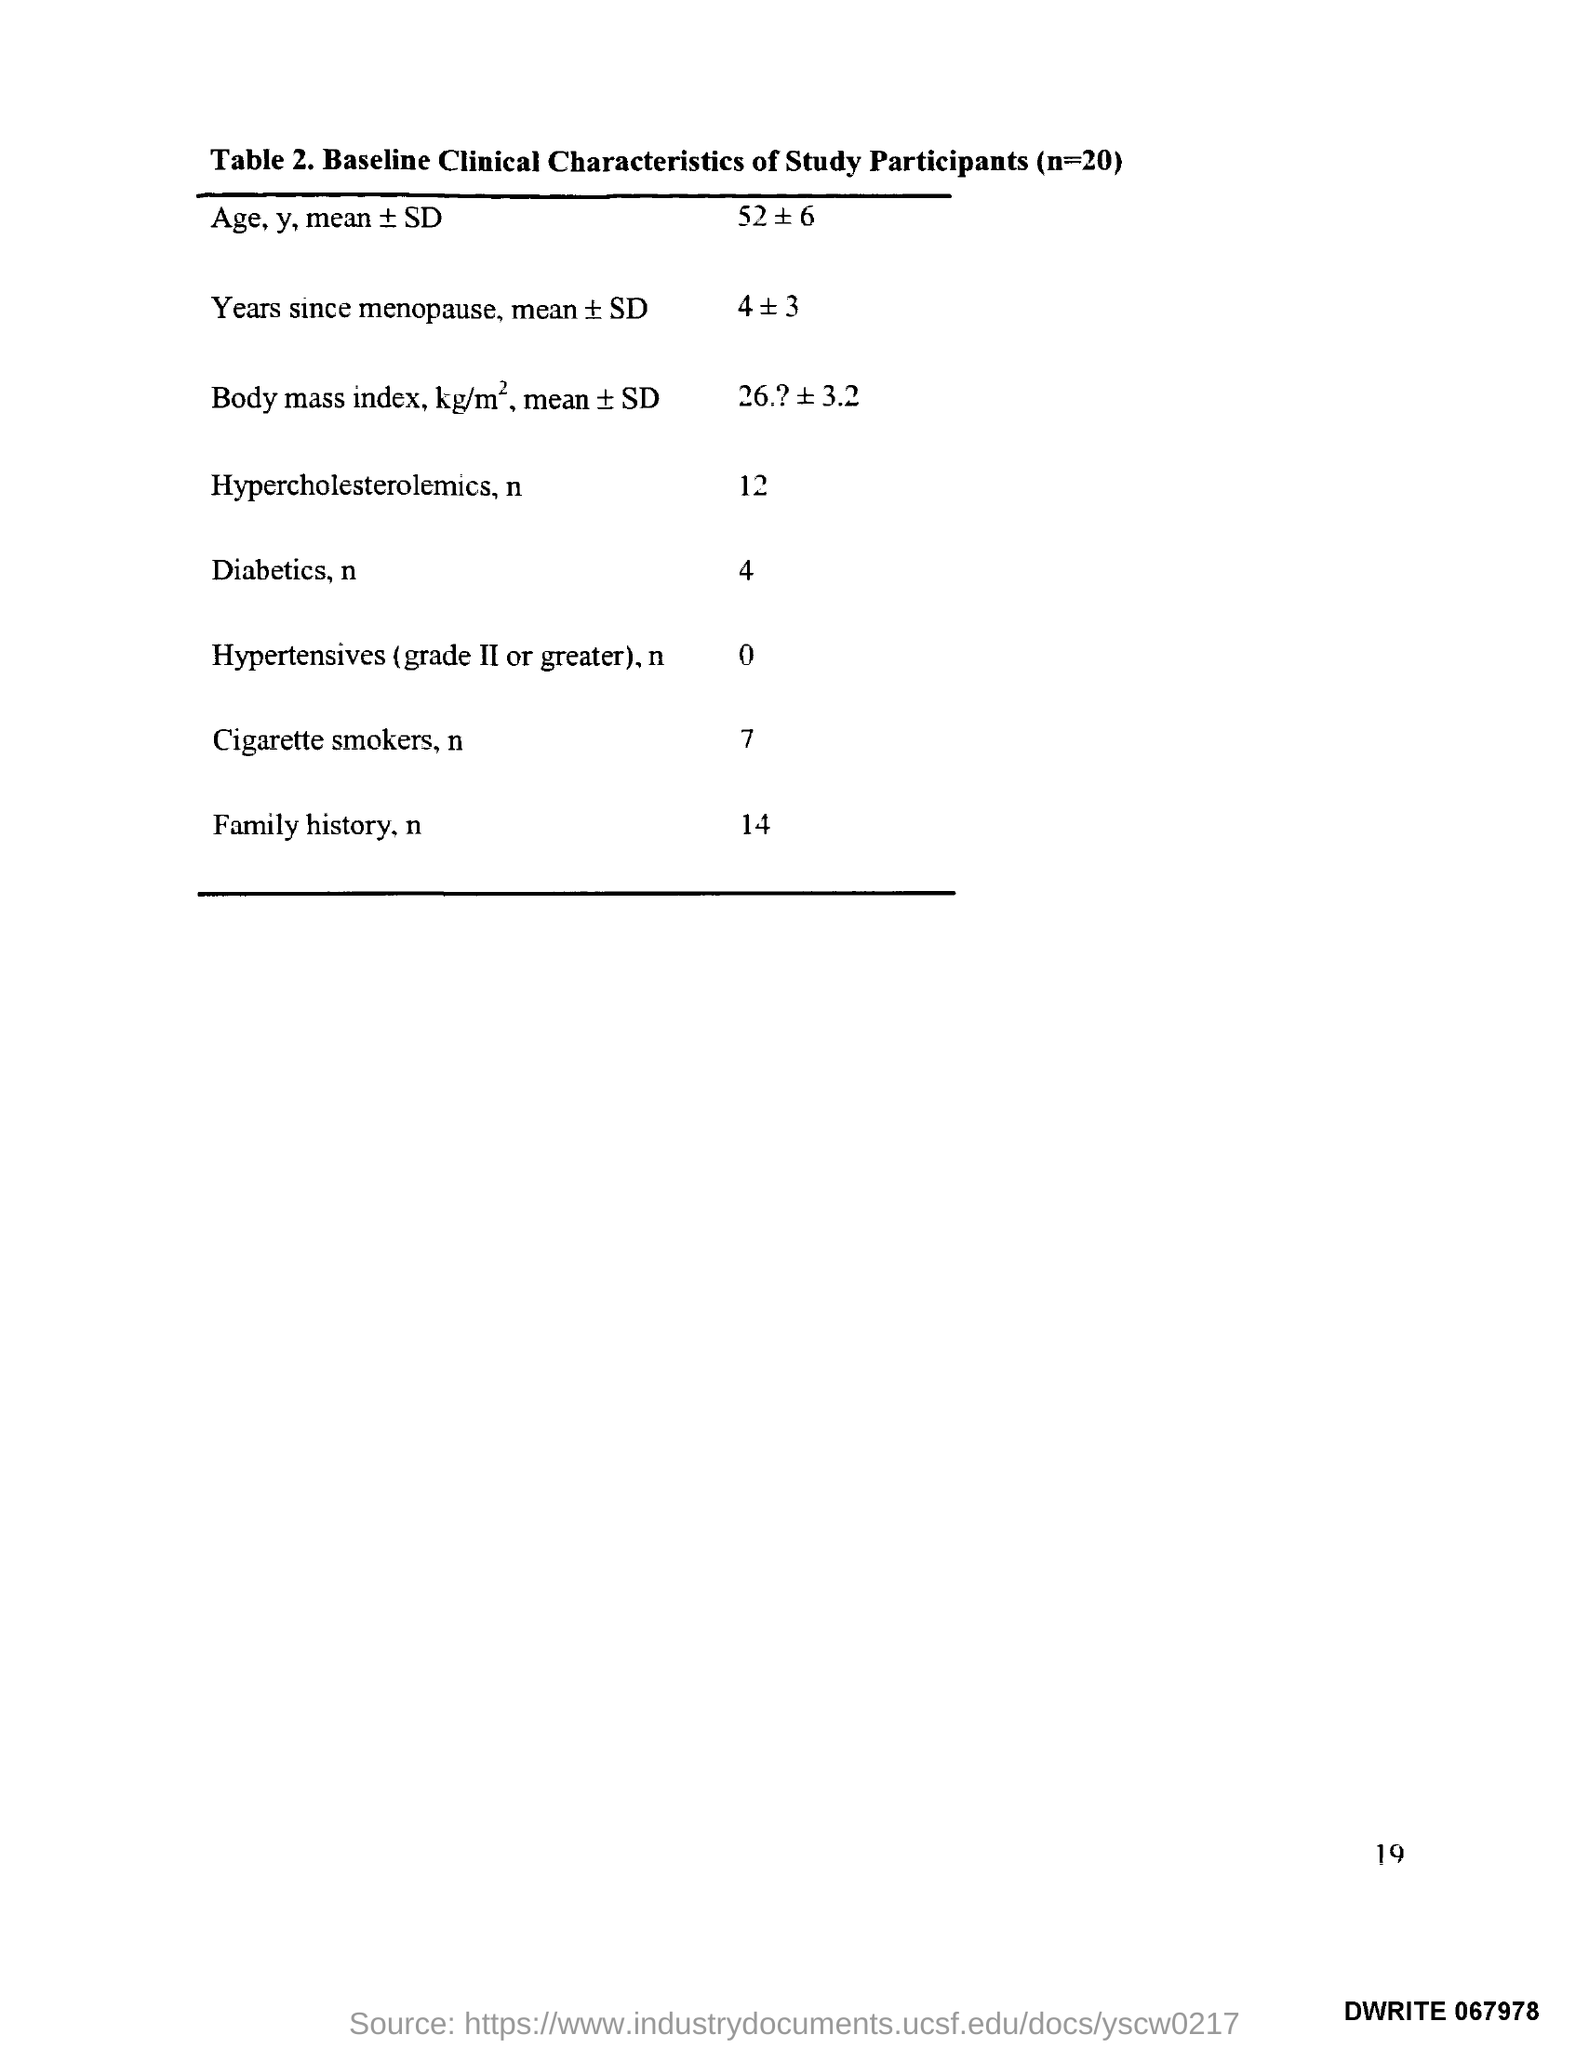Mention a couple of crucial points in this snapshot. The title of Table 2 is "Baseline Clinical Characteristics of Study Participants (n=20). 